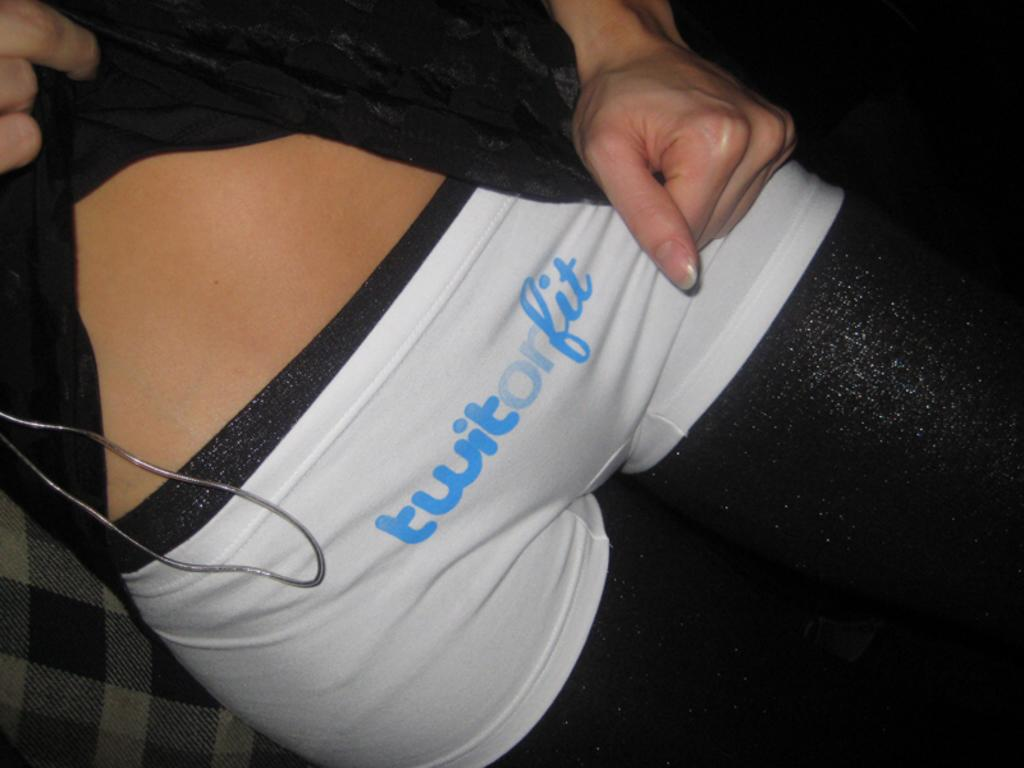<image>
Provide a brief description of the given image. The tiny white shorts say twit or fit. 